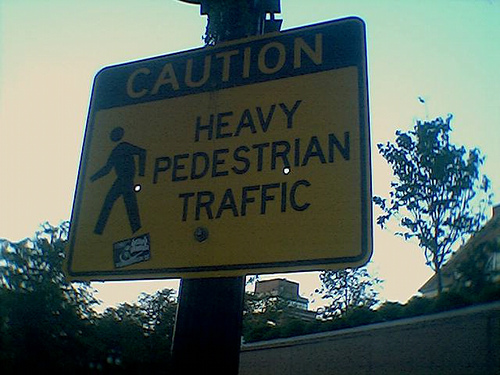Can you describe the time of day or the lighting in the image? The lighting in the image appears to be dim, suggesting that it may have been taken either in the early morning or late evening, when the sun is not very bright. The shadows are soft and not very pronounced, which supports this observation. 